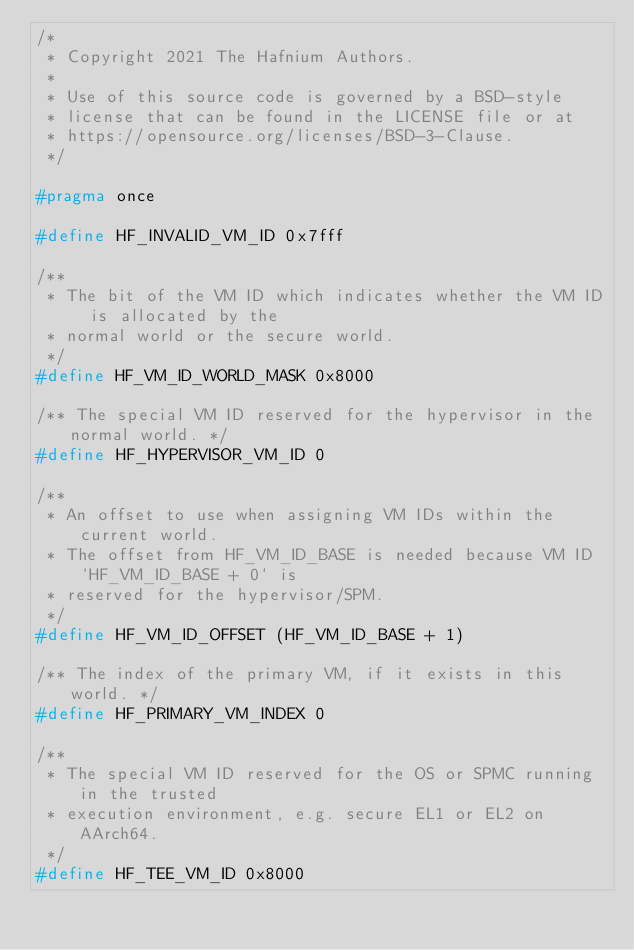<code> <loc_0><loc_0><loc_500><loc_500><_C_>/*
 * Copyright 2021 The Hafnium Authors.
 *
 * Use of this source code is governed by a BSD-style
 * license that can be found in the LICENSE file or at
 * https://opensource.org/licenses/BSD-3-Clause.
 */

#pragma once

#define HF_INVALID_VM_ID 0x7fff

/**
 * The bit of the VM ID which indicates whether the VM ID is allocated by the
 * normal world or the secure world.
 */
#define HF_VM_ID_WORLD_MASK 0x8000

/** The special VM ID reserved for the hypervisor in the normal world. */
#define HF_HYPERVISOR_VM_ID 0

/**
 * An offset to use when assigning VM IDs within the current world.
 * The offset from HF_VM_ID_BASE is needed because VM ID `HF_VM_ID_BASE + 0` is
 * reserved for the hypervisor/SPM.
 */
#define HF_VM_ID_OFFSET (HF_VM_ID_BASE + 1)

/** The index of the primary VM, if it exists in this world. */
#define HF_PRIMARY_VM_INDEX 0

/**
 * The special VM ID reserved for the OS or SPMC running in the trusted
 * execution environment, e.g. secure EL1 or EL2 on AArch64.
 */
#define HF_TEE_VM_ID 0x8000
</code> 